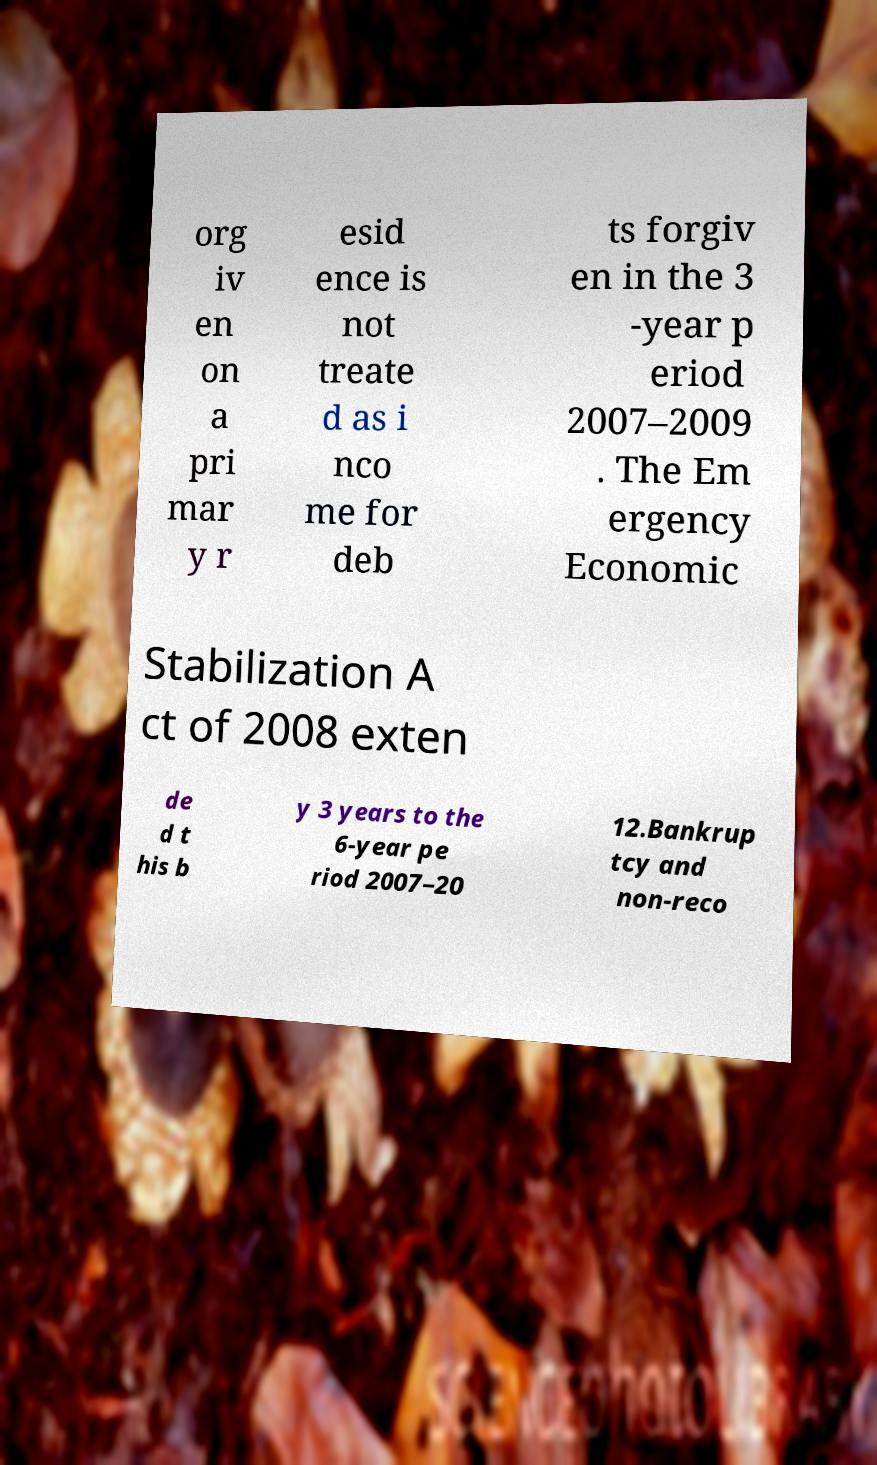Can you accurately transcribe the text from the provided image for me? org iv en on a pri mar y r esid ence is not treate d as i nco me for deb ts forgiv en in the 3 -year p eriod 2007–2009 . The Em ergency Economic Stabilization A ct of 2008 exten de d t his b y 3 years to the 6-year pe riod 2007–20 12.Bankrup tcy and non-reco 